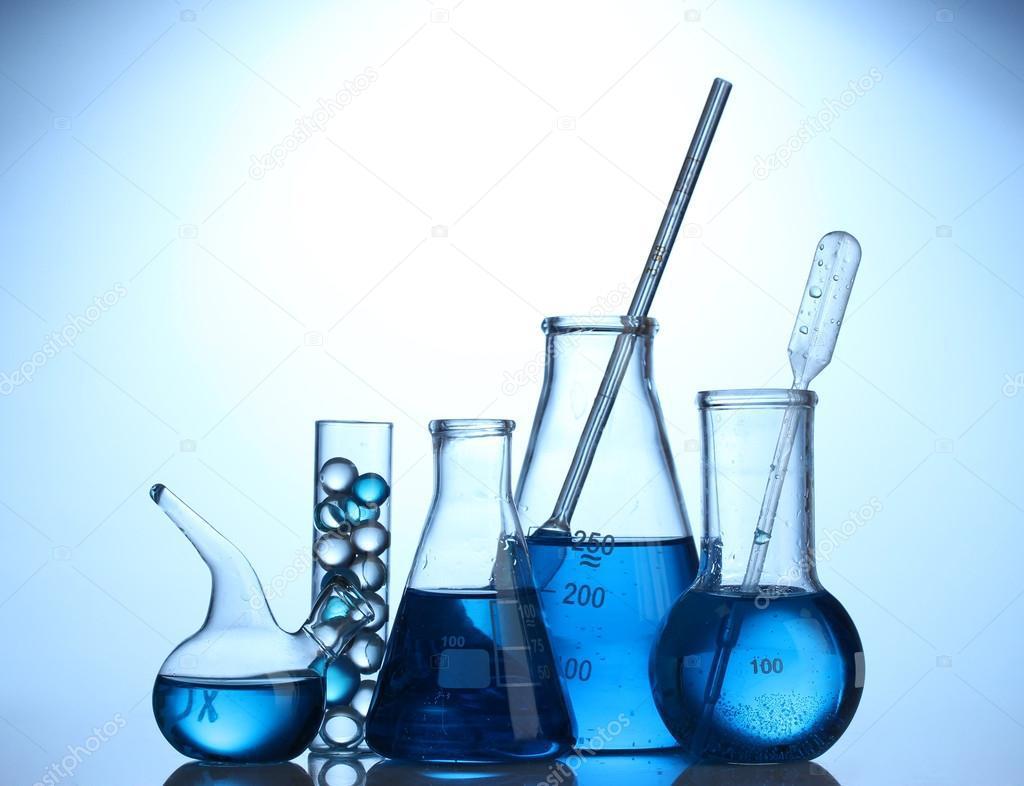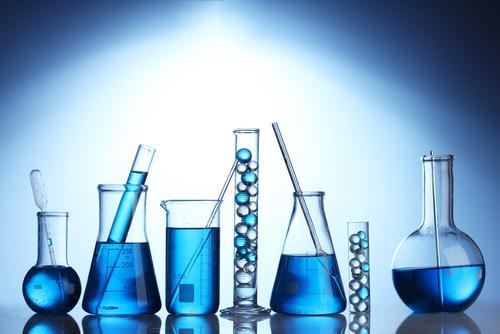The first image is the image on the left, the second image is the image on the right. Given the left and right images, does the statement "A blue light glows behind the containers in the image on the left." hold true? Answer yes or no. Yes. The first image is the image on the left, the second image is the image on the right. For the images displayed, is the sentence "There is at least one beaker straw of stir stick." factually correct? Answer yes or no. Yes. 